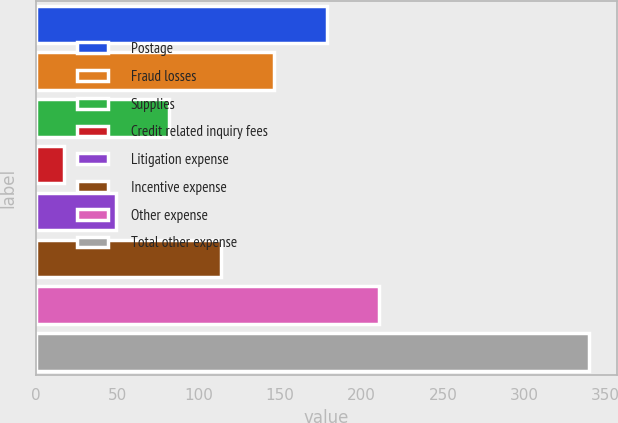<chart> <loc_0><loc_0><loc_500><loc_500><bar_chart><fcel>Postage<fcel>Fraud losses<fcel>Supplies<fcel>Credit related inquiry fees<fcel>Litigation expense<fcel>Incentive expense<fcel>Other expense<fcel>Total other expense<nl><fcel>178.5<fcel>146.2<fcel>81.6<fcel>17<fcel>49.3<fcel>113.9<fcel>210.8<fcel>340<nl></chart> 